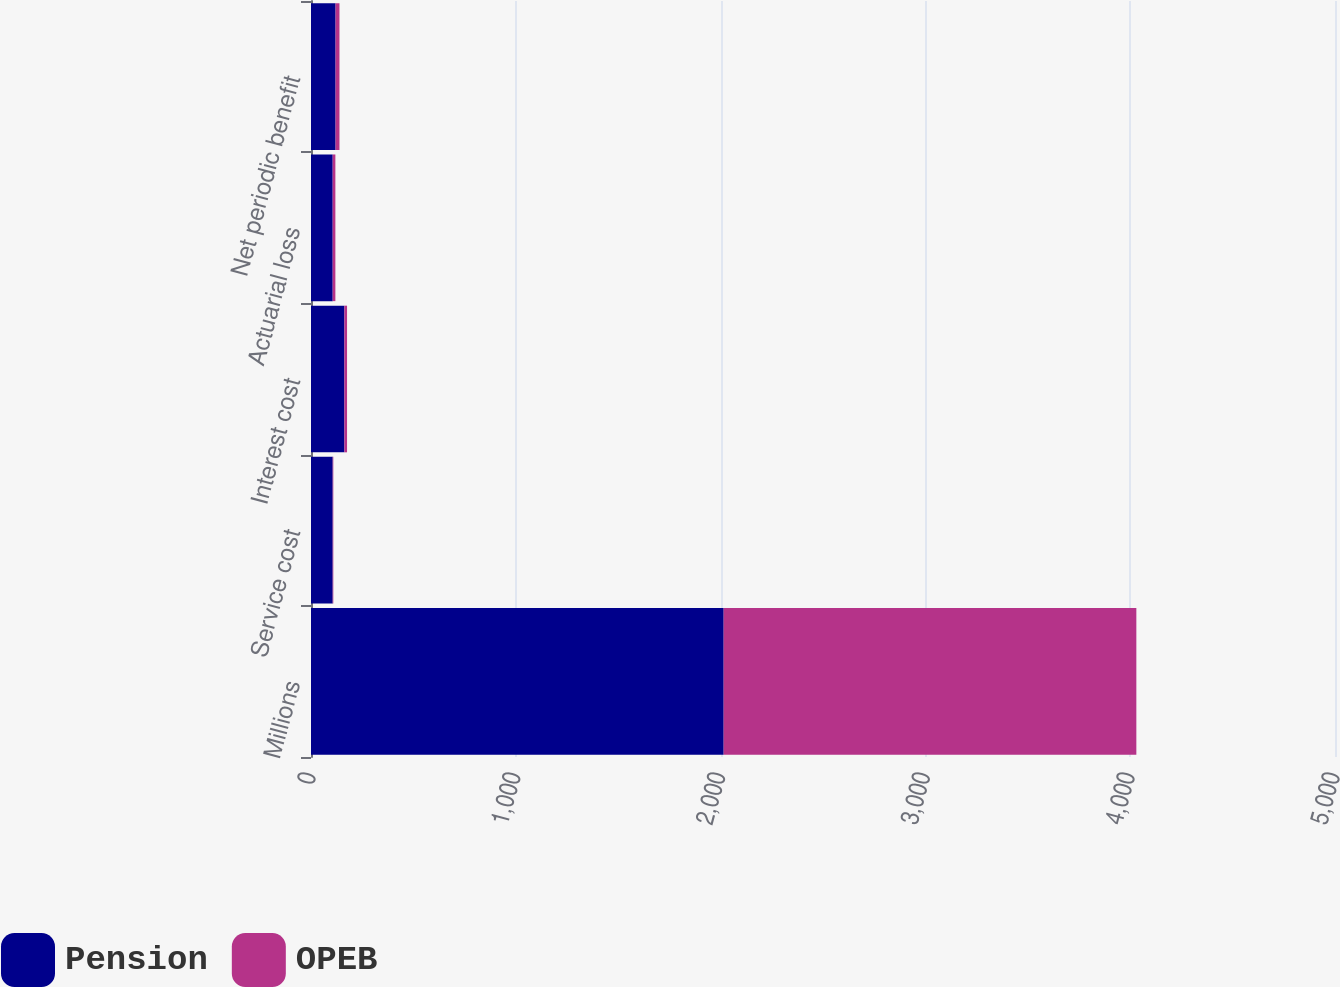<chart> <loc_0><loc_0><loc_500><loc_500><stacked_bar_chart><ecel><fcel>Millions<fcel>Service cost<fcel>Interest cost<fcel>Actuarial loss<fcel>Net periodic benefit<nl><fcel>Pension<fcel>2015<fcel>106<fcel>163<fcel>106<fcel>120<nl><fcel>OPEB<fcel>2015<fcel>3<fcel>13<fcel>13<fcel>19<nl></chart> 